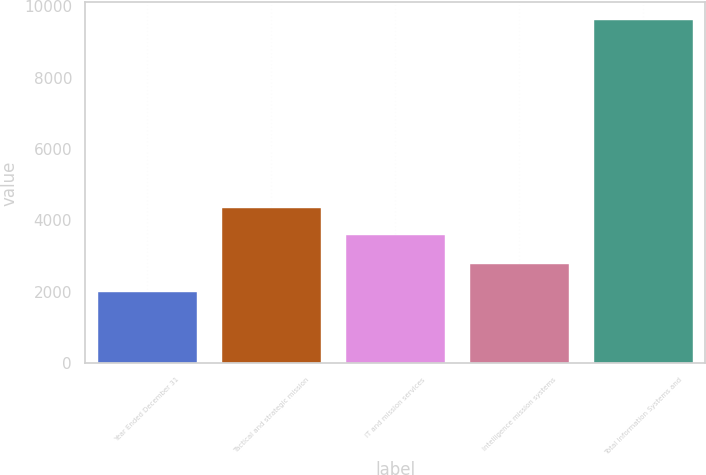Convert chart to OTSL. <chart><loc_0><loc_0><loc_500><loc_500><bar_chart><fcel>Year Ended December 31<fcel>Tactical and strategic mission<fcel>IT and mission services<fcel>Intelligence mission systems<fcel>Total Information Systems and<nl><fcel>2007<fcel>4345.5<fcel>3584<fcel>2768.5<fcel>9622<nl></chart> 